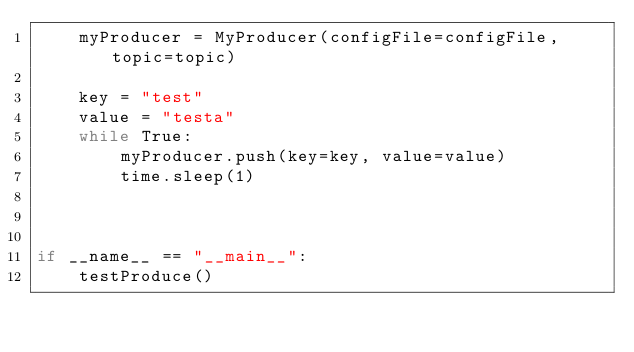Convert code to text. <code><loc_0><loc_0><loc_500><loc_500><_Python_>    myProducer = MyProducer(configFile=configFile, topic=topic)

    key = "test"
    value = "testa"
    while True:
        myProducer.push(key=key, value=value)
        time.sleep(1)



if __name__ == "__main__":
    testProduce()

</code> 